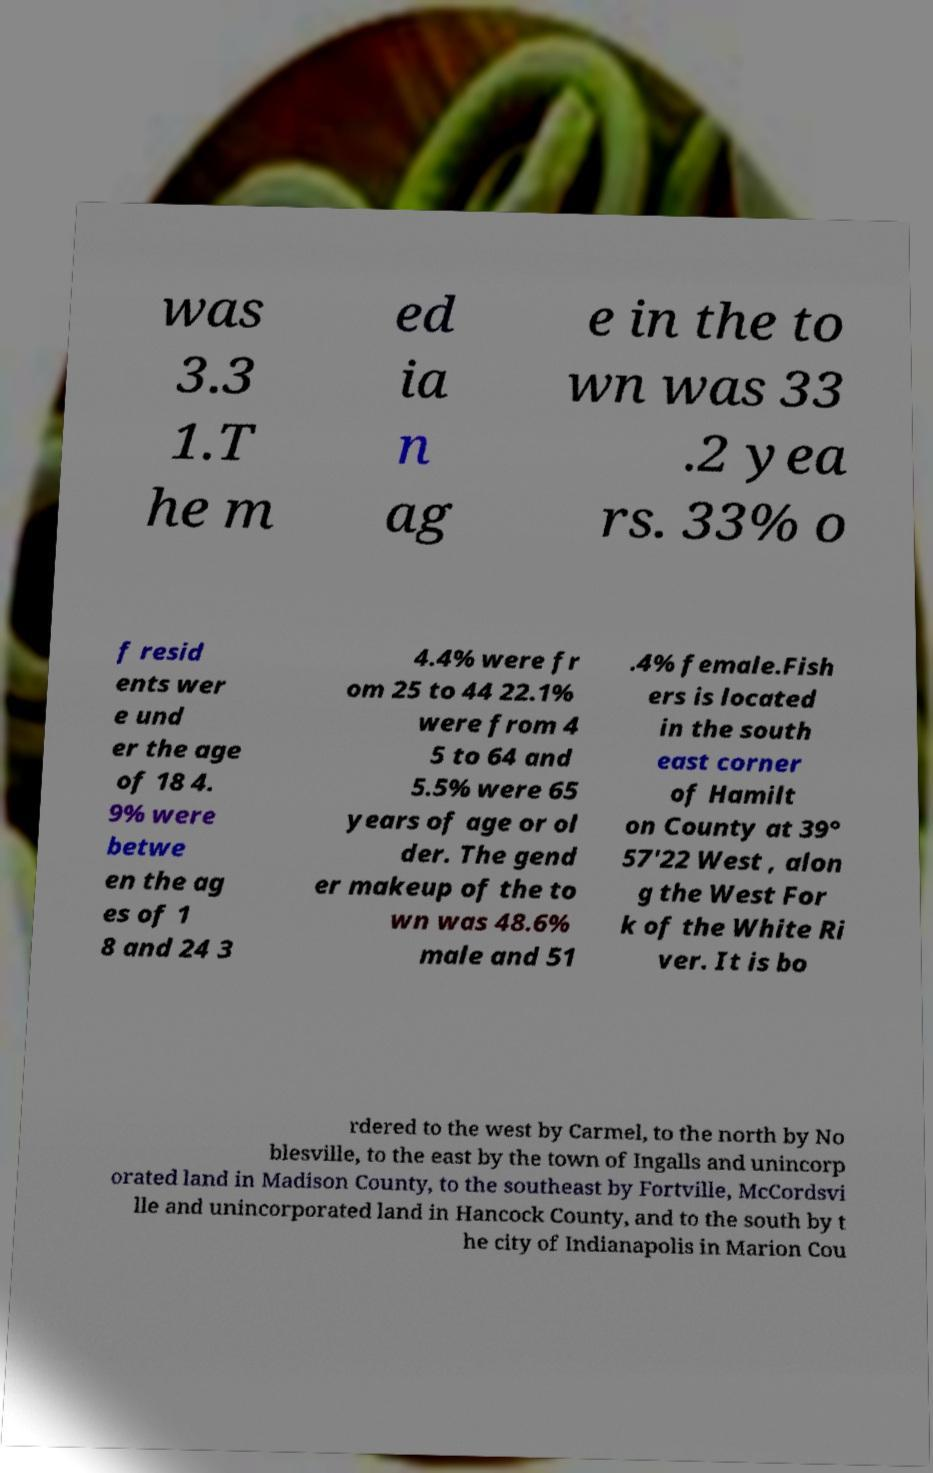What messages or text are displayed in this image? I need them in a readable, typed format. was 3.3 1.T he m ed ia n ag e in the to wn was 33 .2 yea rs. 33% o f resid ents wer e und er the age of 18 4. 9% were betwe en the ag es of 1 8 and 24 3 4.4% were fr om 25 to 44 22.1% were from 4 5 to 64 and 5.5% were 65 years of age or ol der. The gend er makeup of the to wn was 48.6% male and 51 .4% female.Fish ers is located in the south east corner of Hamilt on County at 39° 57'22 West , alon g the West For k of the White Ri ver. It is bo rdered to the west by Carmel, to the north by No blesville, to the east by the town of Ingalls and unincorp orated land in Madison County, to the southeast by Fortville, McCordsvi lle and unincorporated land in Hancock County, and to the south by t he city of Indianapolis in Marion Cou 